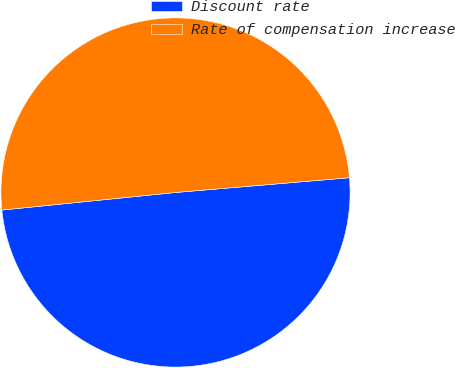<chart> <loc_0><loc_0><loc_500><loc_500><pie_chart><fcel>Discount rate<fcel>Rate of compensation increase<nl><fcel>49.74%<fcel>50.26%<nl></chart> 